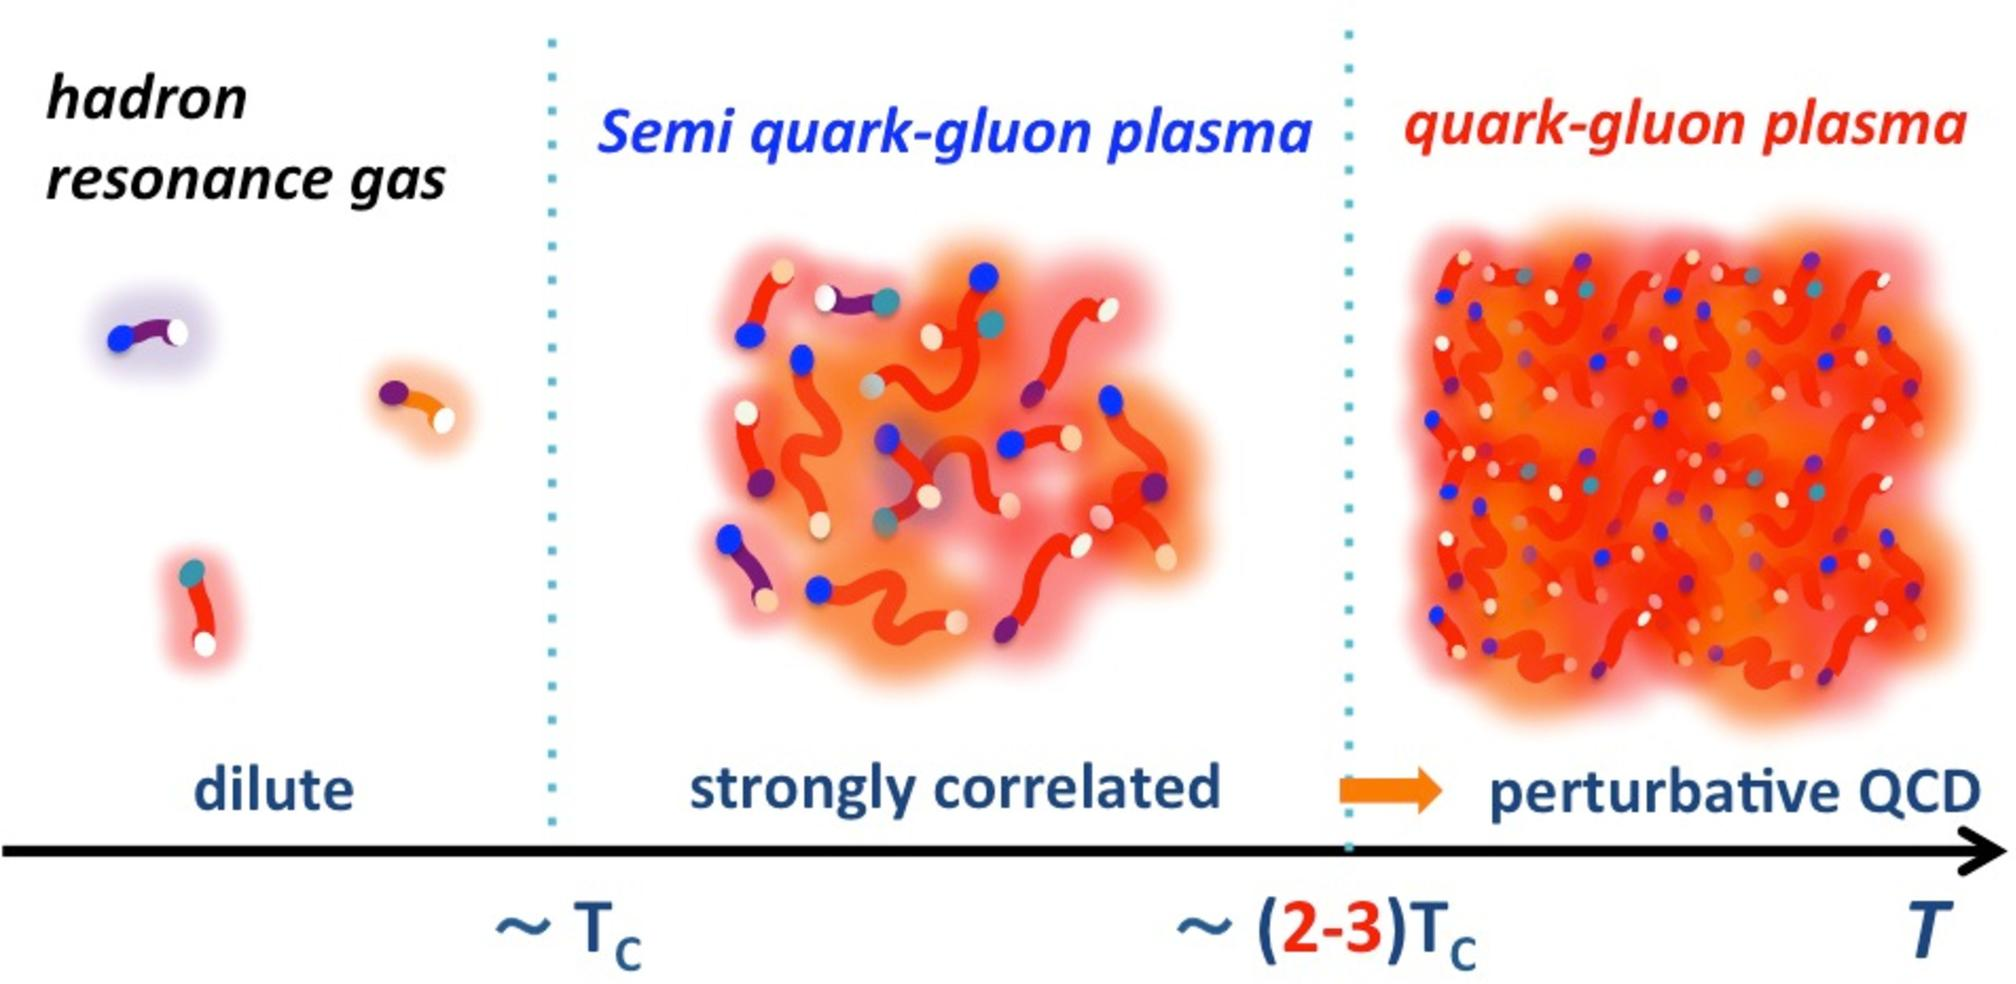What property of the quark-gluon plasma can be inferred from the figure as the temperature increases? A) The color charge of quarks becomes confined. B) The correlation between quarks and gluons decreases. C) The density of the plasma decreases. D) The plasma transitions into a hadron resonance gas. The figure indicates that as the temperature increases from \( T_c \) to \( T \), the state of matter changes from a "semi quark-gluon plasma" to a "quark-gluon plasma," suggesting a decrease in the correlation between quarks and gluons, as they move from a strongly correlated to a perturbative QCD state. Therefore, the correct answer is B. 